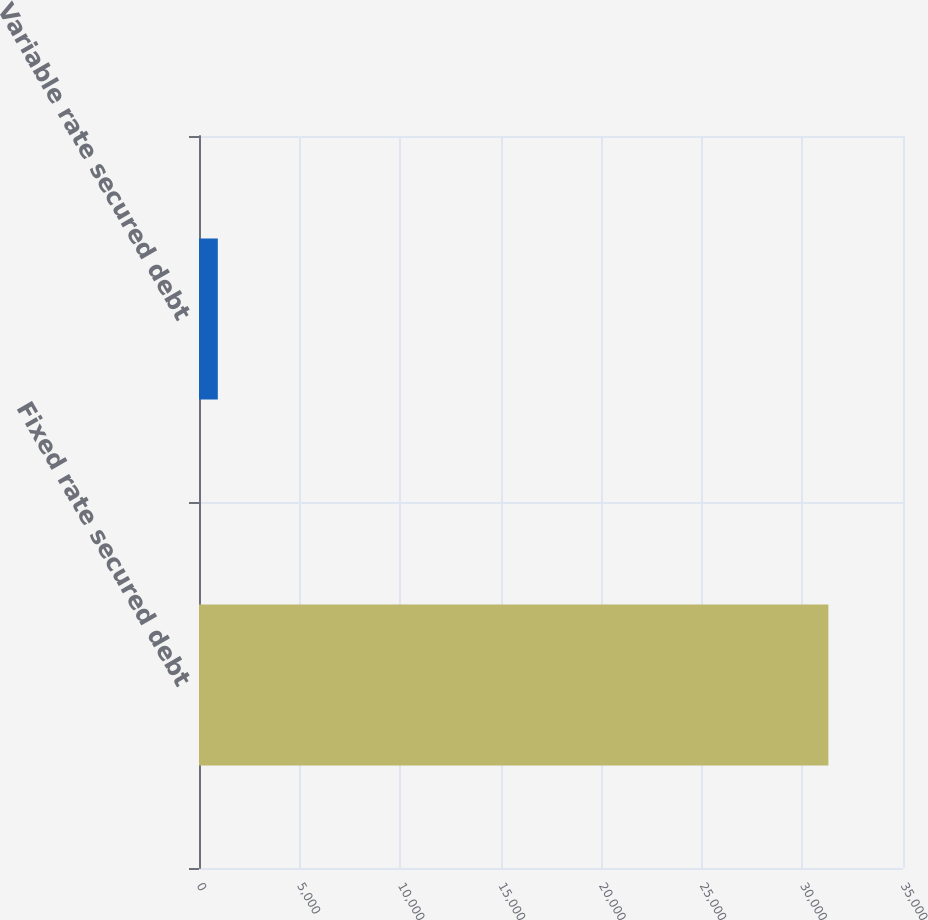Convert chart. <chart><loc_0><loc_0><loc_500><loc_500><bar_chart><fcel>Fixed rate secured debt<fcel>Variable rate secured debt<nl><fcel>31290<fcel>935<nl></chart> 